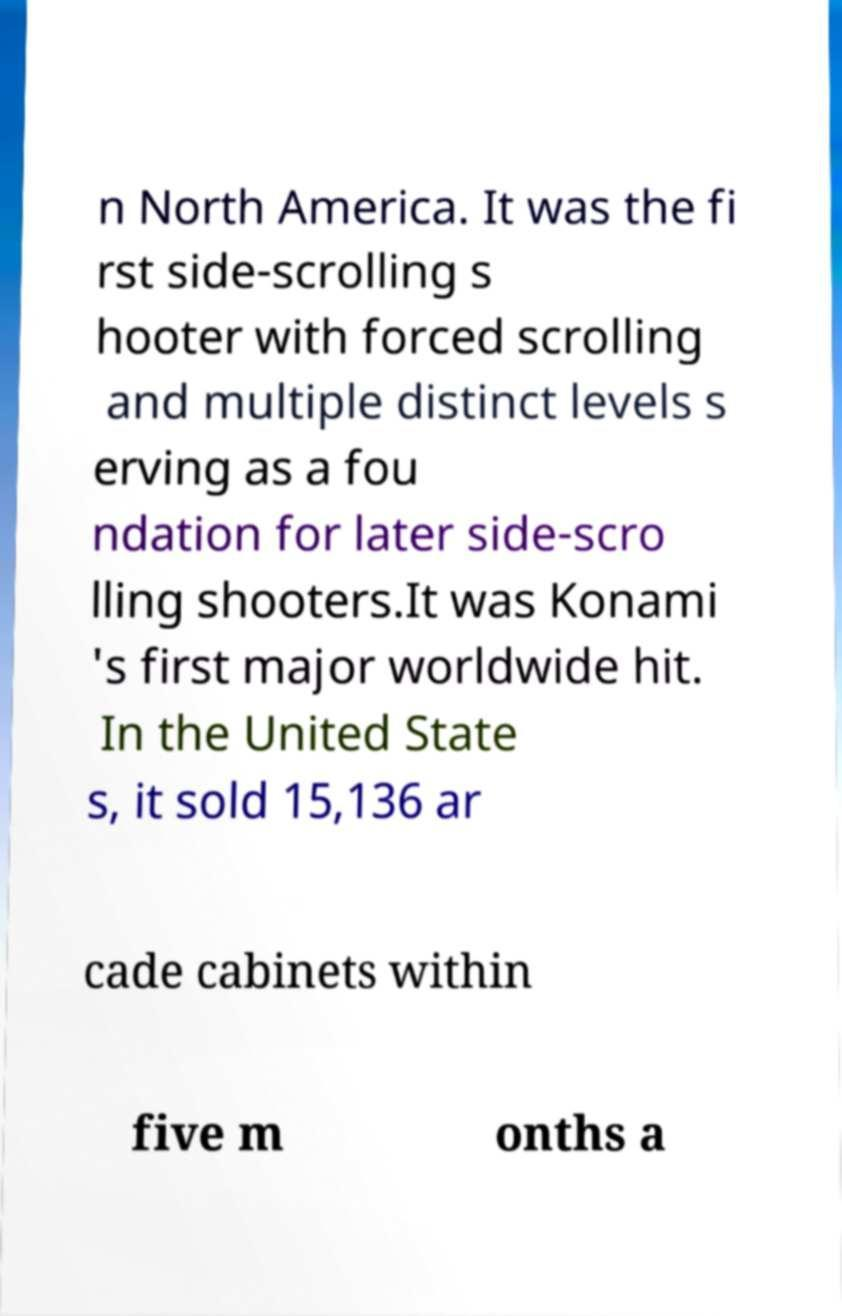For documentation purposes, I need the text within this image transcribed. Could you provide that? n North America. It was the fi rst side-scrolling s hooter with forced scrolling and multiple distinct levels s erving as a fou ndation for later side-scro lling shooters.It was Konami 's first major worldwide hit. In the United State s, it sold 15,136 ar cade cabinets within five m onths a 